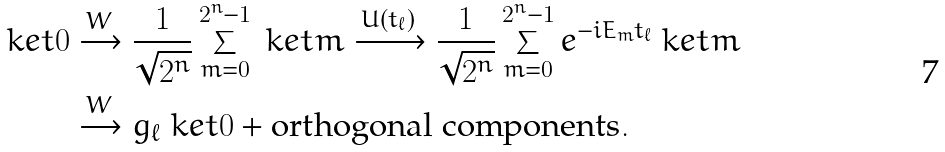<formula> <loc_0><loc_0><loc_500><loc_500>\ k e t { 0 } & \xrightarrow { W } \frac { 1 } { \sqrt { 2 ^ { n } } } \sum _ { m = 0 } ^ { 2 ^ { n } - 1 } \ k e t { m } \xrightarrow { U ( { t _ { \ell } } ) } \frac { 1 } { \sqrt { 2 ^ { n } } } \sum _ { m = 0 } ^ { 2 ^ { n } - 1 } e ^ { - i E _ { m } { t _ { \ell } } } \ k e t { m } \\ & \xrightarrow { W } g _ { \ell } \ k e t { 0 } + \text {orthogonal components} .</formula> 